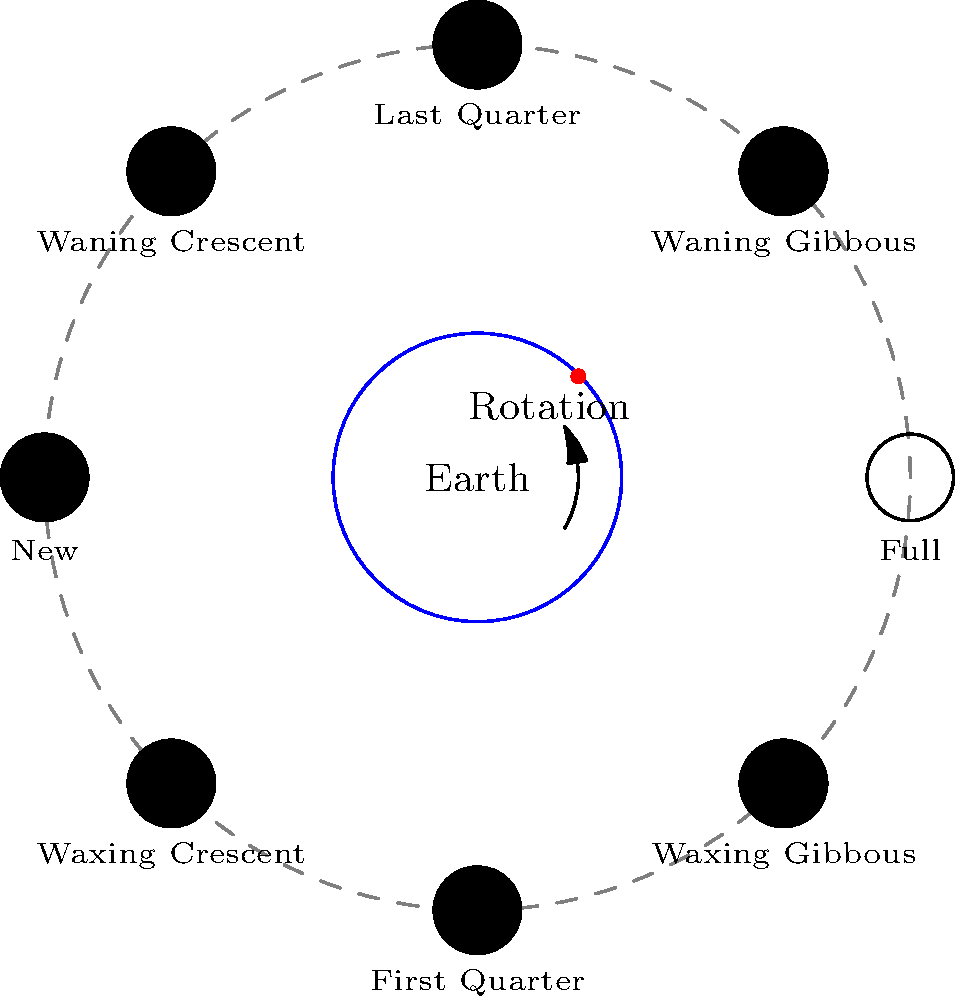In Kōchi Prefecture, which phase of the Moon would be visible in the early evening sky, assuming it's not obstructed by clouds or other atmospheric conditions? To determine which phase of the Moon is visible in the early evening sky from Kōchi Prefecture, we need to consider the following steps:

1. Understand Moon phases:
   - The Moon's phases are caused by its orbit around Earth and the changing angles of sunlight reflection.
   - A complete lunar cycle (from one new moon to the next) takes about 29.5 days.

2. Consider Earth's rotation:
   - Earth rotates counterclockwise when viewed from above the North Pole.
   - Kōchi Prefecture, being in Japan, is on the eastern side of Earth.

3. Analyze early evening visibility:
   - In the early evening, Kōchi Prefecture has just rotated past the point where the Sun is setting.
   - This means the eastern sky is becoming visible as darkness falls.

4. Determine visible Moon phase:
   - The Moon rises in the east and sets in the west, similar to the Sun.
   - Phases visible in the early evening sky would be those that have just risen or are about to rise in the east.

5. Identify the correct phase:
   - The waxing phases (Waxing Crescent, First Quarter, and Waxing Gibbous) are visible in the early evening sky.
   - Among these, the First Quarter moon rises around noon and is high in the sky by early evening.

Therefore, the First Quarter moon would be most prominently visible in the early evening sky from Kōchi Prefecture.
Answer: First Quarter 